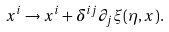Convert formula to latex. <formula><loc_0><loc_0><loc_500><loc_500>x ^ { i } \to x ^ { i } + \delta ^ { i j } \partial _ { j } \xi ( \eta , x ) .</formula> 